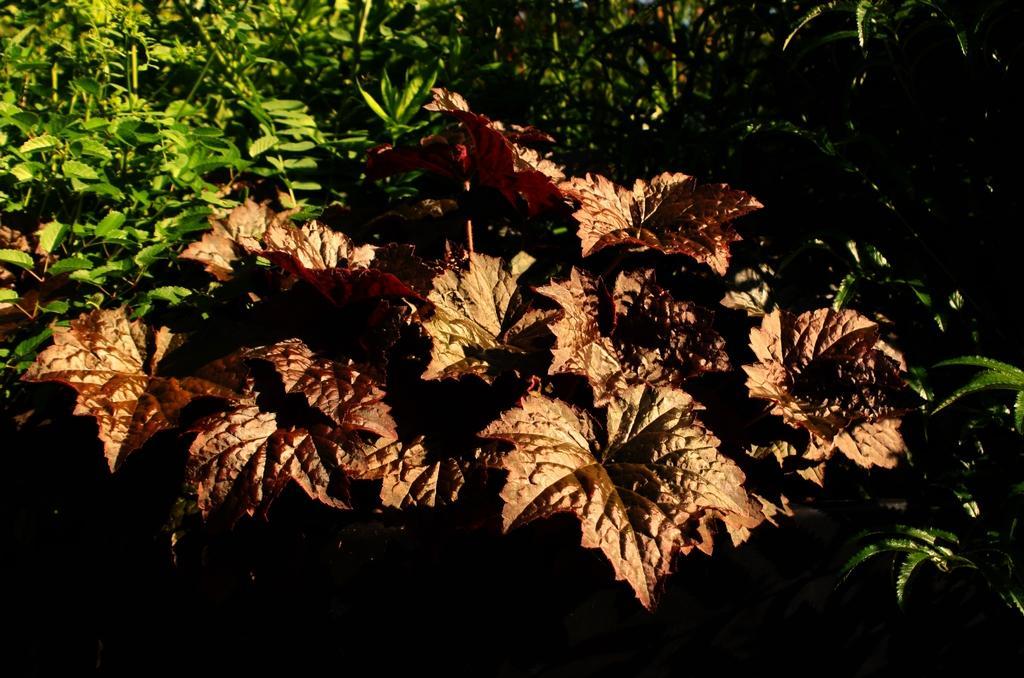Describe this image in one or two sentences. In this picture we can see leaves and in the background we can see plants. 